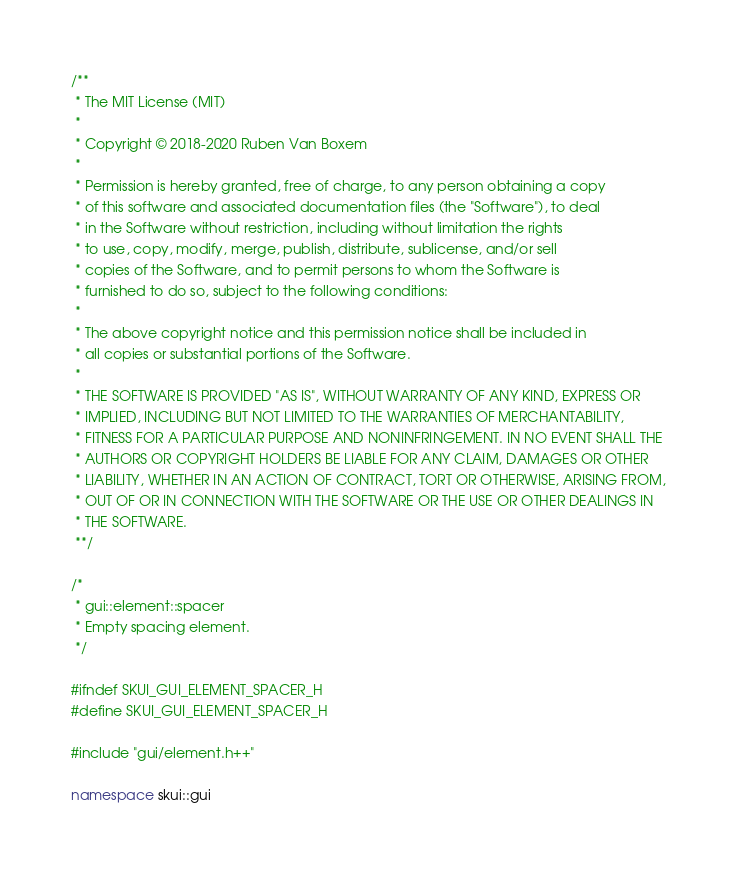<code> <loc_0><loc_0><loc_500><loc_500><_C++_>/**
 * The MIT License (MIT)
 *
 * Copyright © 2018-2020 Ruben Van Boxem
 *
 * Permission is hereby granted, free of charge, to any person obtaining a copy
 * of this software and associated documentation files (the "Software"), to deal
 * in the Software without restriction, including without limitation the rights
 * to use, copy, modify, merge, publish, distribute, sublicense, and/or sell
 * copies of the Software, and to permit persons to whom the Software is
 * furnished to do so, subject to the following conditions:
 *
 * The above copyright notice and this permission notice shall be included in
 * all copies or substantial portions of the Software.
 *
 * THE SOFTWARE IS PROVIDED "AS IS", WITHOUT WARRANTY OF ANY KIND, EXPRESS OR
 * IMPLIED, INCLUDING BUT NOT LIMITED TO THE WARRANTIES OF MERCHANTABILITY,
 * FITNESS FOR A PARTICULAR PURPOSE AND NONINFRINGEMENT. IN NO EVENT SHALL THE
 * AUTHORS OR COPYRIGHT HOLDERS BE LIABLE FOR ANY CLAIM, DAMAGES OR OTHER
 * LIABILITY, WHETHER IN AN ACTION OF CONTRACT, TORT OR OTHERWISE, ARISING FROM,
 * OUT OF OR IN CONNECTION WITH THE SOFTWARE OR THE USE OR OTHER DEALINGS IN
 * THE SOFTWARE.
 **/

/*
 * gui::element::spacer
 * Empty spacing element.
 */

#ifndef SKUI_GUI_ELEMENT_SPACER_H
#define SKUI_GUI_ELEMENT_SPACER_H

#include "gui/element.h++"

namespace skui::gui</code> 